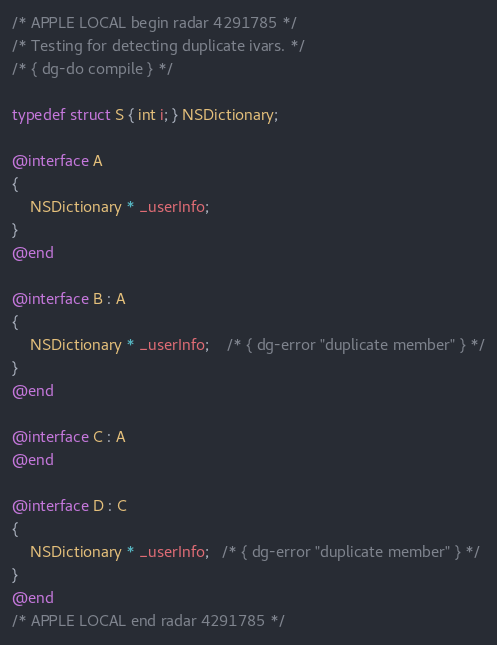Convert code to text. <code><loc_0><loc_0><loc_500><loc_500><_ObjectiveC_>/* APPLE LOCAL begin radar 4291785 */
/* Testing for detecting duplicate ivars. */
/* { dg-do compile } */

typedef struct S { int i; } NSDictionary;

@interface A 
{
    NSDictionary * _userInfo;
}
@end

@interface B : A
{
    NSDictionary * _userInfo;	/* { dg-error "duplicate member" } */
}
@end

@interface C : A
@end

@interface D : C
{
    NSDictionary * _userInfo;   /* { dg-error "duplicate member" } */
}
@end
/* APPLE LOCAL end radar 4291785 */
</code> 